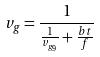Convert formula to latex. <formula><loc_0><loc_0><loc_500><loc_500>v _ { g } = \frac { 1 } { \frac { 1 } { v _ { g _ { 9 } } } + \frac { b t } { f } }</formula> 